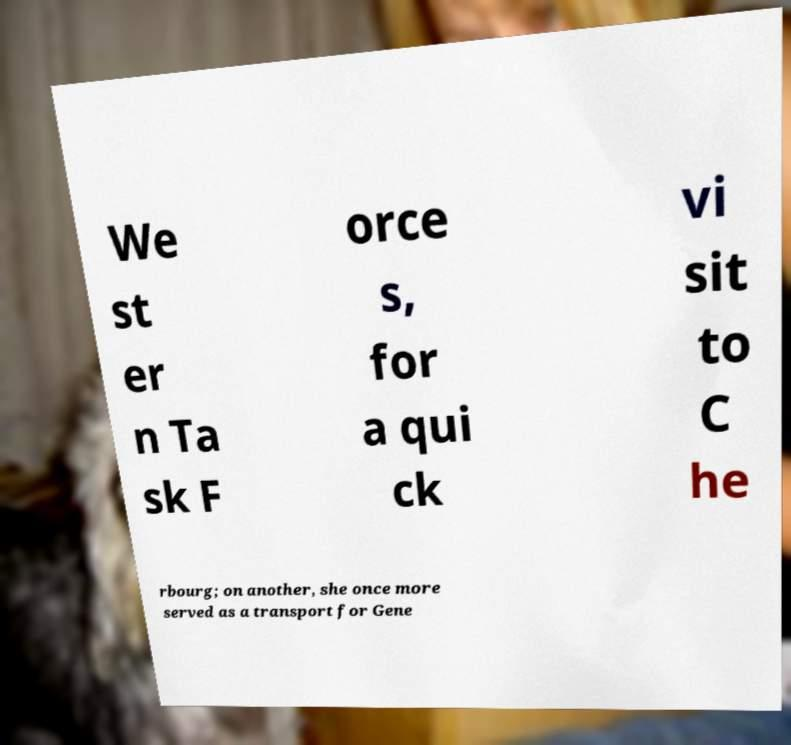Could you assist in decoding the text presented in this image and type it out clearly? We st er n Ta sk F orce s, for a qui ck vi sit to C he rbourg; on another, she once more served as a transport for Gene 